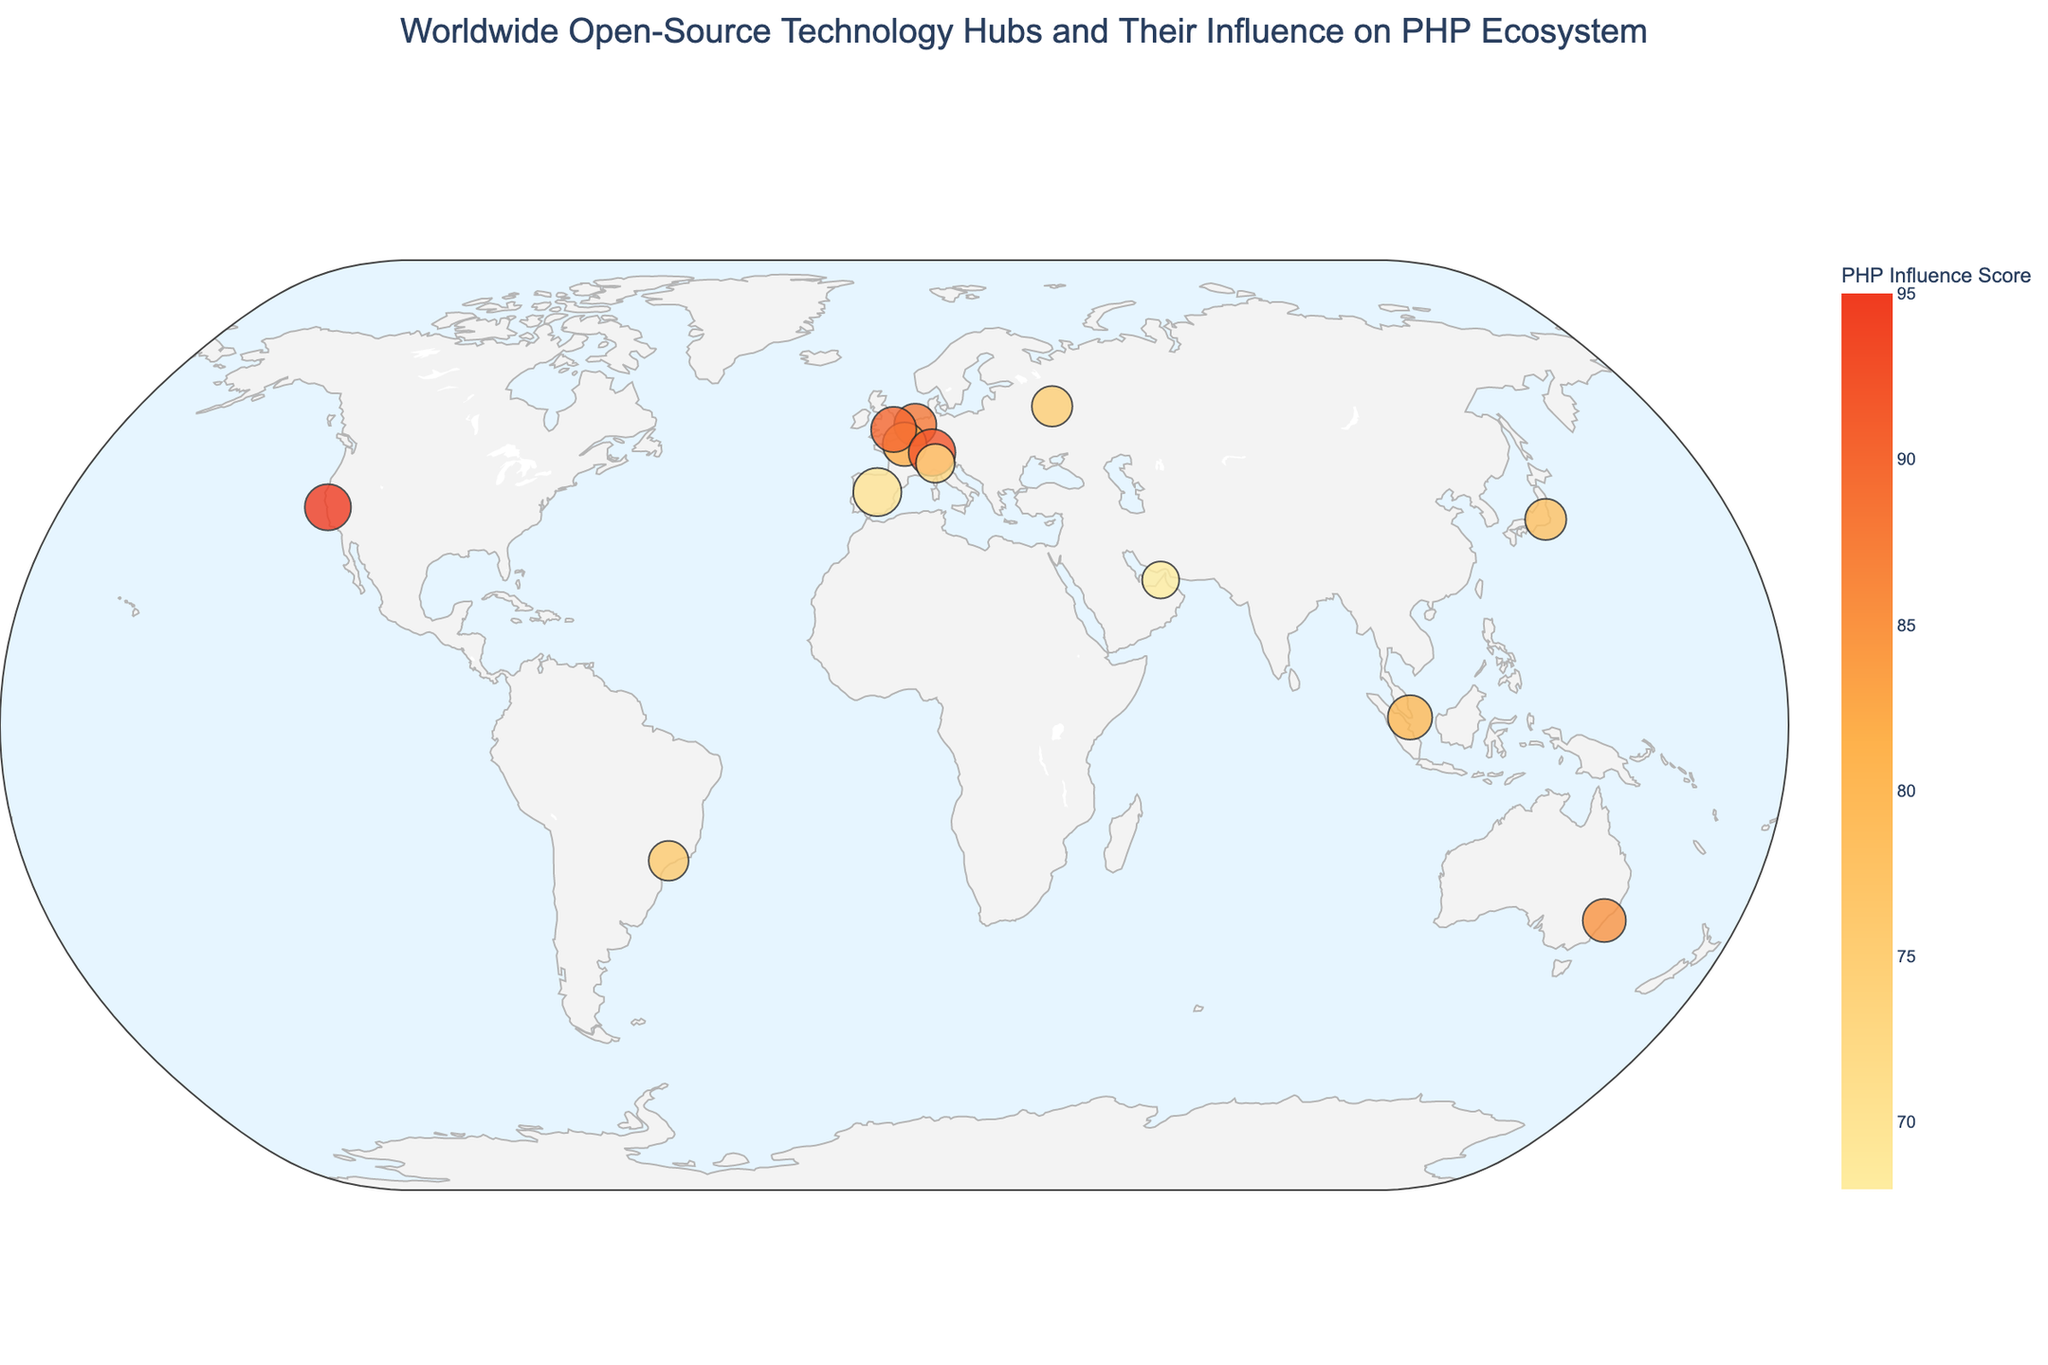How many cities are represented in the figure? By counting the number of cities listed in the data, we can see there are 12 unique cities.
Answer: 12 Which city has the highest Yii adoption rate? According to the data, Madrid, Spain has the highest Yii adoption rate of 85.
Answer: Madrid What is the 'PHP Influence Score' of the hub in Moscow, Russia? The data shows that Moscow, Russia, represented by JetBrains, has a PHP Influence Score of 75.
Answer: 75 How many open-source technology hubs have a PHP Influence Score higher than 80? From the data, San Francisco, Amsterdam, Paris, Sydney, London, Zurich and Singapore all have a PHP Influence Score higher than 80, which makes it 7 hubs in total.
Answer: 7 Which city has both the highest PHP Influence Score and the highest Yii Adoption Rate? Zurich, Switzerland, represented by Zend Technologies has a PHP Influence Score of 92 and a Yii Adoption Rate of 80, both of which are the highest amongst all cities.
Answer: Zurich Which city shows the smallest combination of PHP Influence Score and Yii Adoption Rate? Taking smallest sum of PHP Influence Score and Yii Adoption Rate, Dubai, UAE with a score of 68 and rate of 50 sums up to 118, the smallest among all.
Answer: Dubai What is the difference in the Yii Adoption Rates between the tech hubs in Paris and Sydney? Paris has a Yii Adoption Rate of 70 and Sydney has 68; thus, the difference is 70 - 68 = 2.
Answer: 2 Which techno-hub located outside Europe has the highest PHP Influence Score? Based on the locations outside Europe (i.e., USA, Singapore, Australia, Japan, UAE, and Brazil), the hub in San Francisco, USA has the highest PHP Influence Score of 95.
Answer: San Francisco How does the Yii Adoption Rate of the Tokyo hub compare to that of Milan? Tokyo, Japan has a Yii Adoption Rate of 62 while Milan, Italy has a rate of 55. Hence Tokyo's rate is 7 points higher than Milan's.
Answer: Tokyo What is the general trend between PHP Influence Score and Yii Adoption Rate in the plotted hubs? Most of the hubs exhibit a positive correlation, where higher PHP Influence Scores tend to align with higher Yii Adoption Rates. This is observed in cities like Zurich, London, and San Francisco.
Answer: Positive correlation 